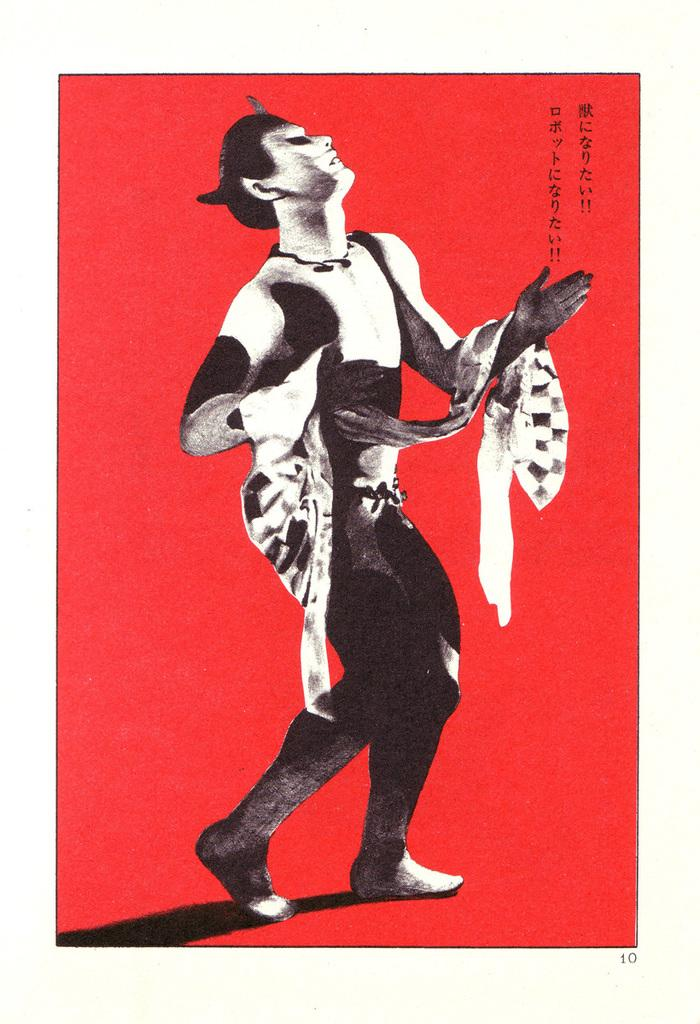What color is the background of the image? The background of the image is red. What can be seen in the foreground of the image? There is a man standing in the image. What else is visible in the image besides the man? The shadow of the man's legs is visible in the image. What type of furniture can be seen in the image? There is no furniture present in the image. Is there a hole visible in the image? There is no hole visible in the image. Can you spot a snake in the image? There is no snake present in the image. 